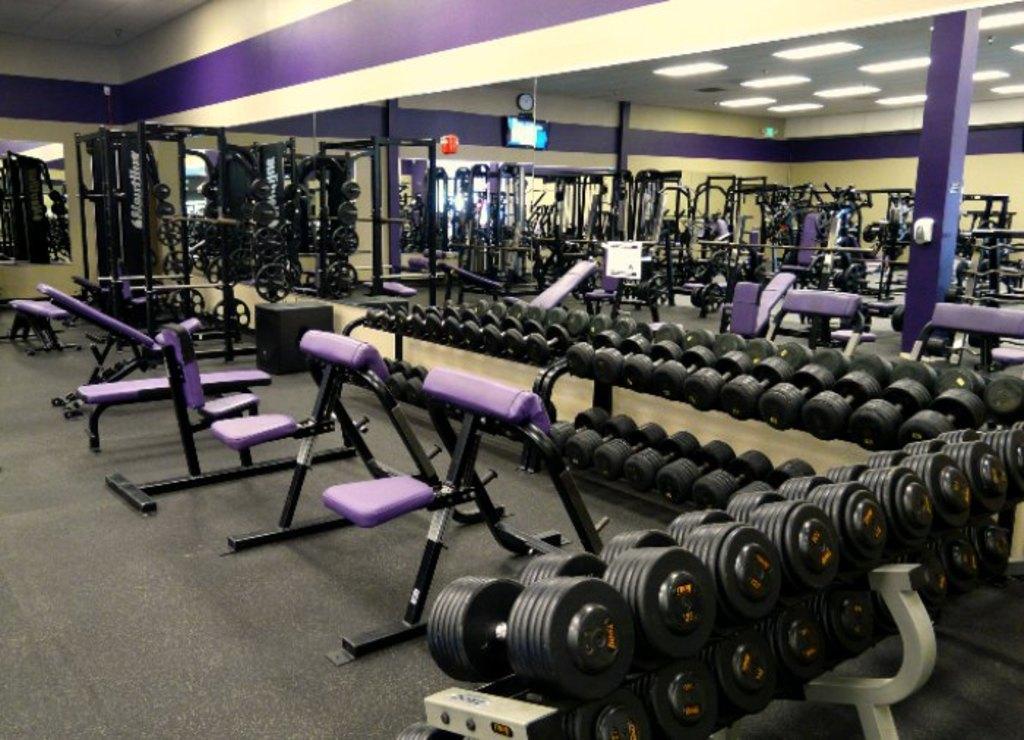In one or two sentences, can you explain what this image depicts? In this picture we can see dumbbells, exercise equipment on the floor and in the background we can see the lights, walls, pillars, screen, clock and some objects. 